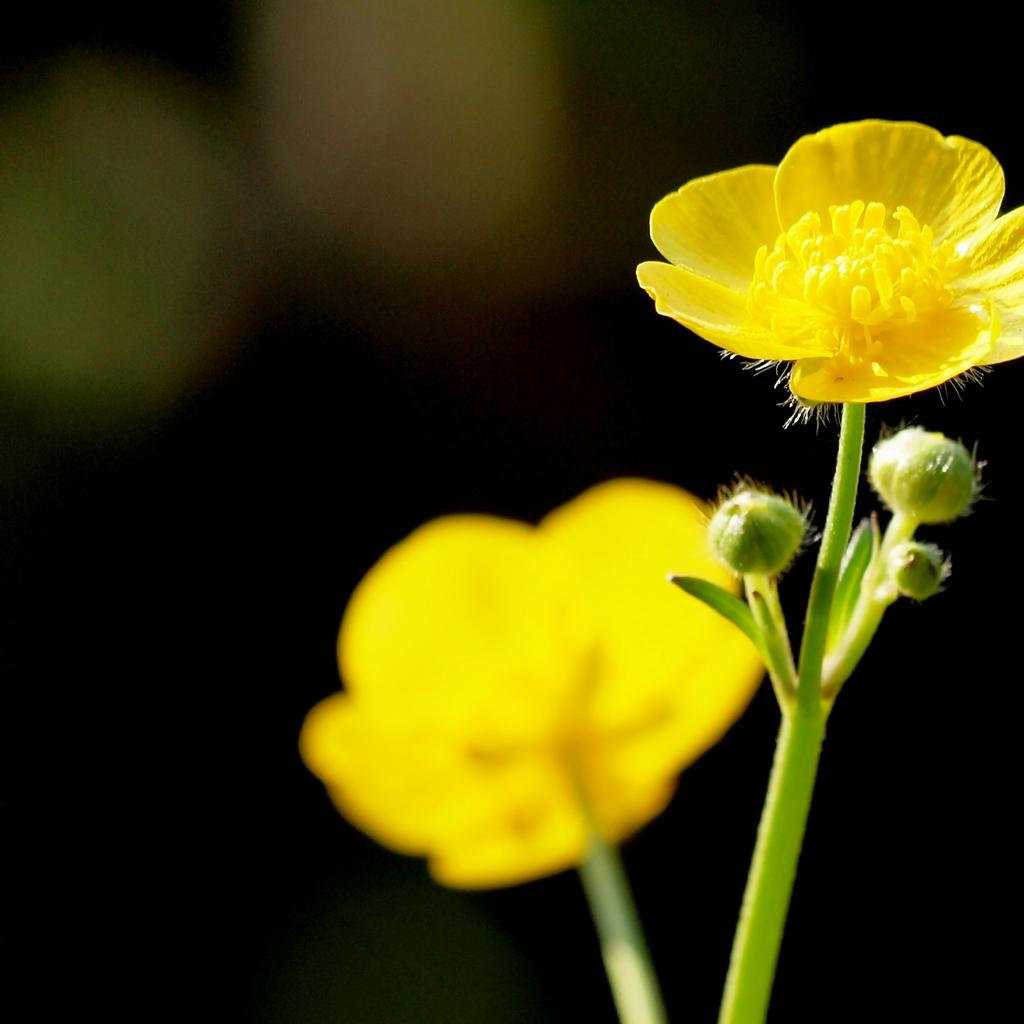What type of flowers can be seen in the image? There are yellow colored flowers in the image. What type of stocking is being used to hold the flowers in the image? There is no stocking present in the image; the flowers are not being held by any stocking. 